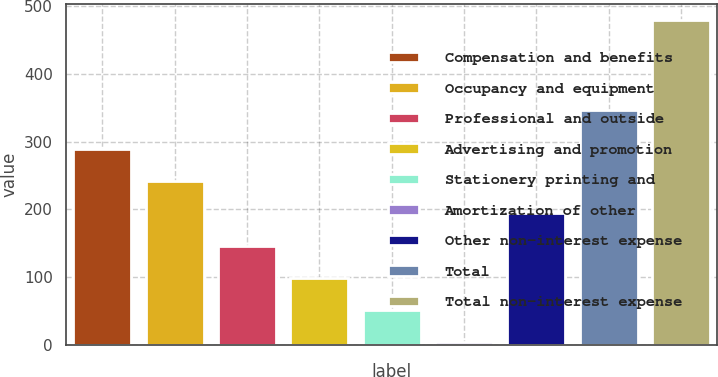Convert chart to OTSL. <chart><loc_0><loc_0><loc_500><loc_500><bar_chart><fcel>Compensation and benefits<fcel>Occupancy and equipment<fcel>Professional and outside<fcel>Advertising and promotion<fcel>Stationery printing and<fcel>Amortization of other<fcel>Other non-interest expense<fcel>Total<fcel>Total non-interest expense<nl><fcel>289.18<fcel>241.55<fcel>146.29<fcel>98.66<fcel>51.03<fcel>3.4<fcel>193.92<fcel>346.3<fcel>479.7<nl></chart> 